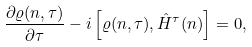<formula> <loc_0><loc_0><loc_500><loc_500>\frac { \partial \varrho ( n , \tau ) } { \partial \tau } - i \left [ \varrho ( n , \tau ) , \hat { H } ^ { \tau } ( n ) \right ] = 0 ,</formula> 